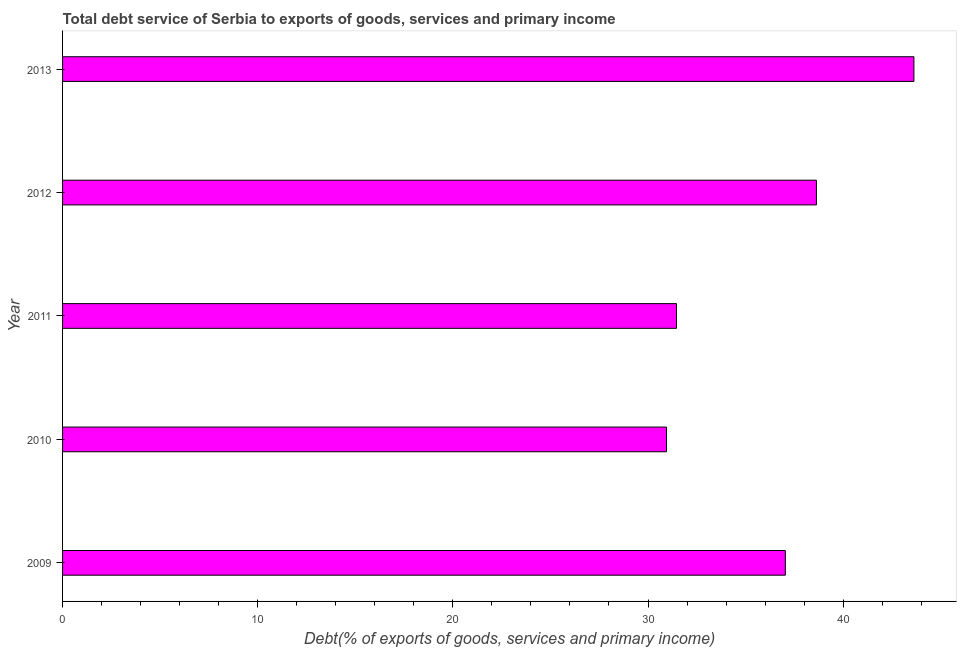What is the title of the graph?
Keep it short and to the point. Total debt service of Serbia to exports of goods, services and primary income. What is the label or title of the X-axis?
Your answer should be compact. Debt(% of exports of goods, services and primary income). What is the label or title of the Y-axis?
Provide a succinct answer. Year. What is the total debt service in 2011?
Your answer should be compact. 31.46. Across all years, what is the maximum total debt service?
Give a very brief answer. 43.63. Across all years, what is the minimum total debt service?
Keep it short and to the point. 30.95. In which year was the total debt service maximum?
Ensure brevity in your answer.  2013. What is the sum of the total debt service?
Your answer should be compact. 181.7. What is the difference between the total debt service in 2009 and 2010?
Your response must be concise. 6.09. What is the average total debt service per year?
Provide a succinct answer. 36.34. What is the median total debt service?
Offer a very short reply. 37.04. What is the ratio of the total debt service in 2010 to that in 2012?
Your answer should be compact. 0.8. Is the total debt service in 2009 less than that in 2011?
Offer a terse response. No. Is the difference between the total debt service in 2009 and 2012 greater than the difference between any two years?
Provide a short and direct response. No. What is the difference between the highest and the second highest total debt service?
Your response must be concise. 5. Is the sum of the total debt service in 2011 and 2012 greater than the maximum total debt service across all years?
Offer a terse response. Yes. What is the difference between the highest and the lowest total debt service?
Offer a very short reply. 12.68. In how many years, is the total debt service greater than the average total debt service taken over all years?
Ensure brevity in your answer.  3. How many years are there in the graph?
Keep it short and to the point. 5. Are the values on the major ticks of X-axis written in scientific E-notation?
Offer a terse response. No. What is the Debt(% of exports of goods, services and primary income) of 2009?
Offer a very short reply. 37.04. What is the Debt(% of exports of goods, services and primary income) in 2010?
Keep it short and to the point. 30.95. What is the Debt(% of exports of goods, services and primary income) in 2011?
Offer a very short reply. 31.46. What is the Debt(% of exports of goods, services and primary income) in 2012?
Give a very brief answer. 38.63. What is the Debt(% of exports of goods, services and primary income) of 2013?
Offer a very short reply. 43.63. What is the difference between the Debt(% of exports of goods, services and primary income) in 2009 and 2010?
Make the answer very short. 6.09. What is the difference between the Debt(% of exports of goods, services and primary income) in 2009 and 2011?
Ensure brevity in your answer.  5.58. What is the difference between the Debt(% of exports of goods, services and primary income) in 2009 and 2012?
Your answer should be compact. -1.59. What is the difference between the Debt(% of exports of goods, services and primary income) in 2009 and 2013?
Your answer should be compact. -6.59. What is the difference between the Debt(% of exports of goods, services and primary income) in 2010 and 2011?
Provide a short and direct response. -0.51. What is the difference between the Debt(% of exports of goods, services and primary income) in 2010 and 2012?
Give a very brief answer. -7.68. What is the difference between the Debt(% of exports of goods, services and primary income) in 2010 and 2013?
Your response must be concise. -12.68. What is the difference between the Debt(% of exports of goods, services and primary income) in 2011 and 2012?
Keep it short and to the point. -7.17. What is the difference between the Debt(% of exports of goods, services and primary income) in 2011 and 2013?
Keep it short and to the point. -12.16. What is the difference between the Debt(% of exports of goods, services and primary income) in 2012 and 2013?
Your response must be concise. -5. What is the ratio of the Debt(% of exports of goods, services and primary income) in 2009 to that in 2010?
Give a very brief answer. 1.2. What is the ratio of the Debt(% of exports of goods, services and primary income) in 2009 to that in 2011?
Your response must be concise. 1.18. What is the ratio of the Debt(% of exports of goods, services and primary income) in 2009 to that in 2013?
Keep it short and to the point. 0.85. What is the ratio of the Debt(% of exports of goods, services and primary income) in 2010 to that in 2012?
Provide a succinct answer. 0.8. What is the ratio of the Debt(% of exports of goods, services and primary income) in 2010 to that in 2013?
Provide a short and direct response. 0.71. What is the ratio of the Debt(% of exports of goods, services and primary income) in 2011 to that in 2012?
Ensure brevity in your answer.  0.81. What is the ratio of the Debt(% of exports of goods, services and primary income) in 2011 to that in 2013?
Give a very brief answer. 0.72. What is the ratio of the Debt(% of exports of goods, services and primary income) in 2012 to that in 2013?
Offer a terse response. 0.89. 